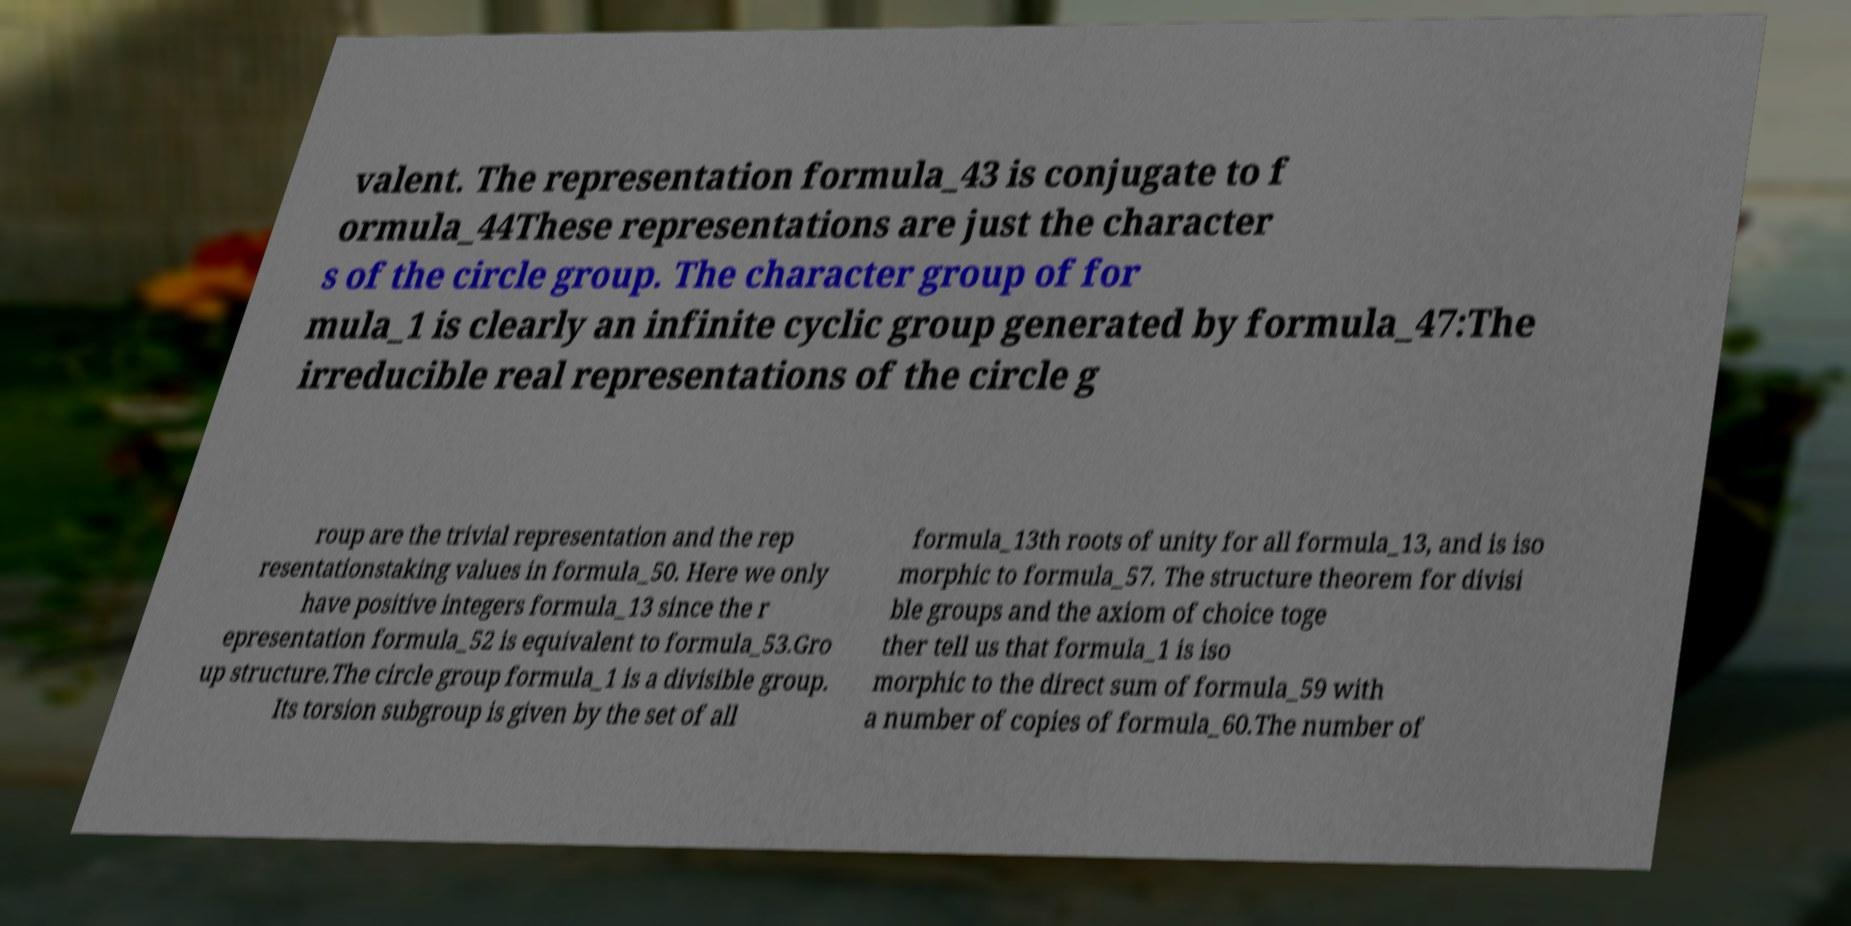Could you assist in decoding the text presented in this image and type it out clearly? valent. The representation formula_43 is conjugate to f ormula_44These representations are just the character s of the circle group. The character group of for mula_1 is clearly an infinite cyclic group generated by formula_47:The irreducible real representations of the circle g roup are the trivial representation and the rep resentationstaking values in formula_50. Here we only have positive integers formula_13 since the r epresentation formula_52 is equivalent to formula_53.Gro up structure.The circle group formula_1 is a divisible group. Its torsion subgroup is given by the set of all formula_13th roots of unity for all formula_13, and is iso morphic to formula_57. The structure theorem for divisi ble groups and the axiom of choice toge ther tell us that formula_1 is iso morphic to the direct sum of formula_59 with a number of copies of formula_60.The number of 